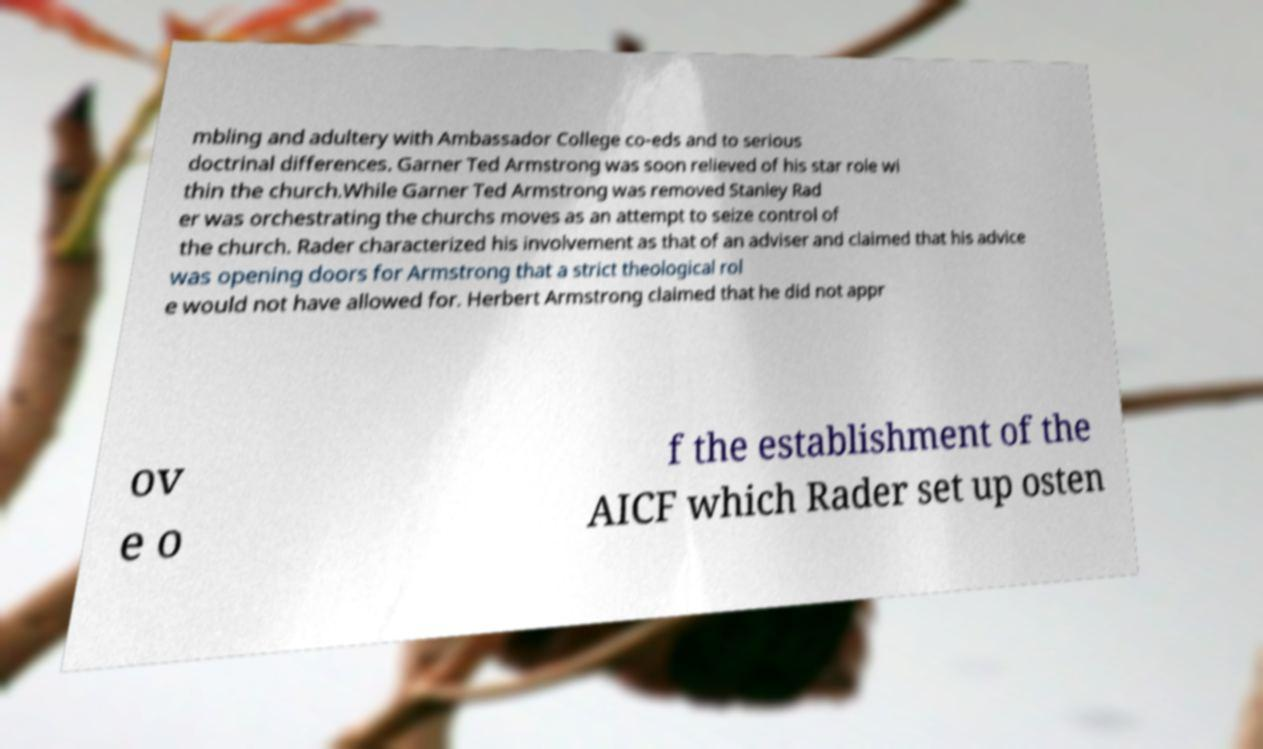Could you assist in decoding the text presented in this image and type it out clearly? mbling and adultery with Ambassador College co-eds and to serious doctrinal differences. Garner Ted Armstrong was soon relieved of his star role wi thin the church.While Garner Ted Armstrong was removed Stanley Rad er was orchestrating the churchs moves as an attempt to seize control of the church. Rader characterized his involvement as that of an adviser and claimed that his advice was opening doors for Armstrong that a strict theological rol e would not have allowed for. Herbert Armstrong claimed that he did not appr ov e o f the establishment of the AICF which Rader set up osten 